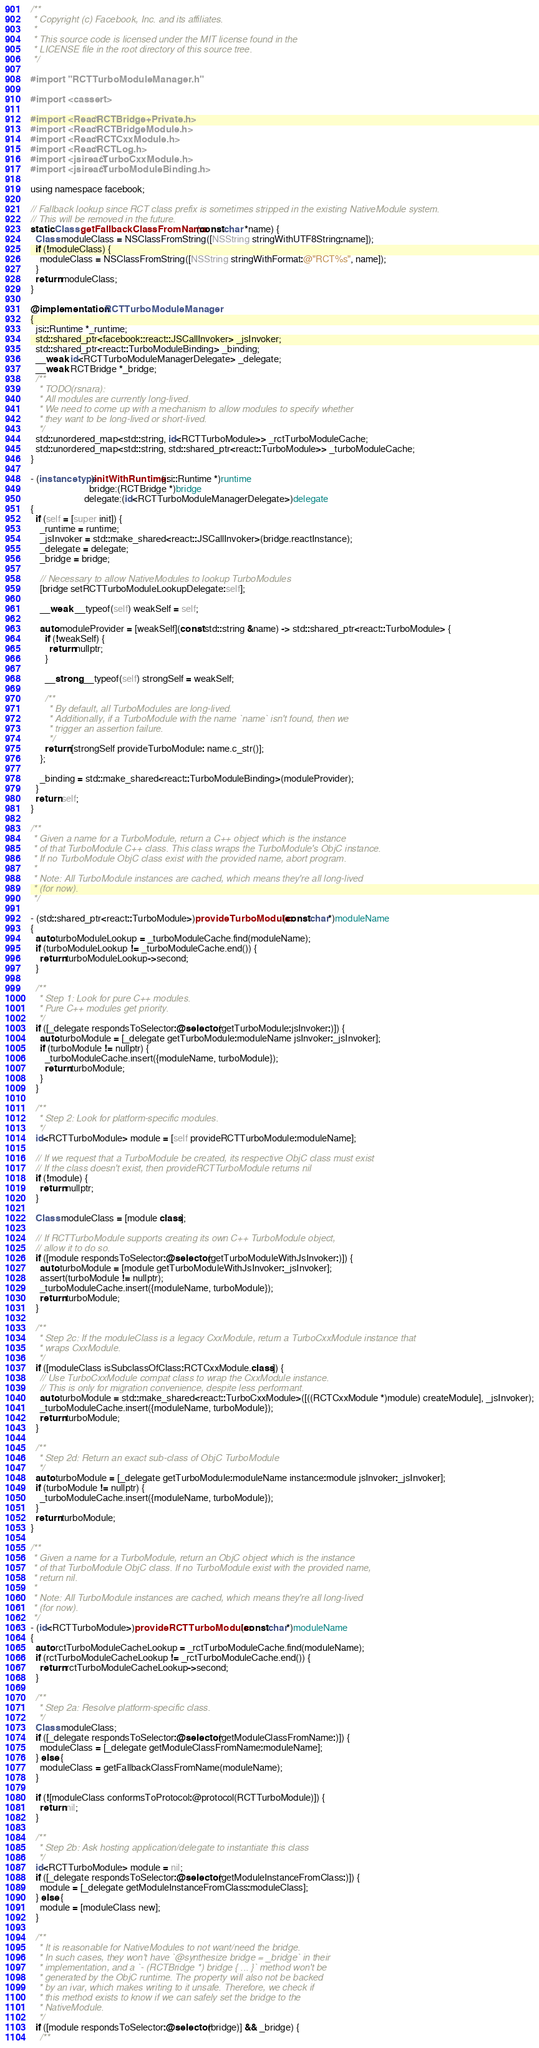<code> <loc_0><loc_0><loc_500><loc_500><_ObjectiveC_>/**
 * Copyright (c) Facebook, Inc. and its affiliates.
 *
 * This source code is licensed under the MIT license found in the
 * LICENSE file in the root directory of this source tree.
 */

#import "RCTTurboModuleManager.h"

#import <cassert>

#import <React/RCTBridge+Private.h>
#import <React/RCTBridgeModule.h>
#import <React/RCTCxxModule.h>
#import <React/RCTLog.h>
#import <jsireact/TurboCxxModule.h>
#import <jsireact/TurboModuleBinding.h>

using namespace facebook;

// Fallback lookup since RCT class prefix is sometimes stripped in the existing NativeModule system.
// This will be removed in the future.
static Class getFallbackClassFromName(const char *name) {
  Class moduleClass = NSClassFromString([NSString stringWithUTF8String:name]);
  if (!moduleClass) {
    moduleClass = NSClassFromString([NSString stringWithFormat:@"RCT%s", name]);
  }
  return moduleClass;
}

@implementation RCTTurboModuleManager
{
  jsi::Runtime *_runtime;
  std::shared_ptr<facebook::react::JSCallInvoker> _jsInvoker;
  std::shared_ptr<react::TurboModuleBinding> _binding;
  __weak id<RCTTurboModuleManagerDelegate> _delegate;
  __weak RCTBridge *_bridge;
  /**
   * TODO(rsnara):
   * All modules are currently long-lived.
   * We need to come up with a mechanism to allow modules to specify whether
   * they want to be long-lived or short-lived.
   */
  std::unordered_map<std::string, id<RCTTurboModule>> _rctTurboModuleCache;
  std::unordered_map<std::string, std::shared_ptr<react::TurboModule>> _turboModuleCache;
}

- (instancetype)initWithRuntime:(jsi::Runtime *)runtime
                         bridge:(RCTBridge *)bridge
                       delegate:(id<RCTTurboModuleManagerDelegate>)delegate
{
  if (self = [super init]) {
    _runtime = runtime;
    _jsInvoker = std::make_shared<react::JSCallInvoker>(bridge.reactInstance);
    _delegate = delegate;
    _bridge = bridge;

    // Necessary to allow NativeModules to lookup TurboModules
    [bridge setRCTTurboModuleLookupDelegate:self];

    __weak __typeof(self) weakSelf = self;

    auto moduleProvider = [weakSelf](const std::string &name) -> std::shared_ptr<react::TurboModule> {
      if (!weakSelf) {
        return nullptr;
      }

      __strong __typeof(self) strongSelf = weakSelf;

      /**
       * By default, all TurboModules are long-lived.
       * Additionally, if a TurboModule with the name `name` isn't found, then we
       * trigger an assertion failure.
       */
      return [strongSelf provideTurboModule: name.c_str()];
    };

    _binding = std::make_shared<react::TurboModuleBinding>(moduleProvider);
  }
  return self;
}

/**
 * Given a name for a TurboModule, return a C++ object which is the instance
 * of that TurboModule C++ class. This class wraps the TurboModule's ObjC instance.
 * If no TurboModule ObjC class exist with the provided name, abort program.
 *
 * Note: All TurboModule instances are cached, which means they're all long-lived
 * (for now).
 */

- (std::shared_ptr<react::TurboModule>)provideTurboModule:(const char*)moduleName
{
  auto turboModuleLookup = _turboModuleCache.find(moduleName);
  if (turboModuleLookup != _turboModuleCache.end()) {
    return turboModuleLookup->second;
  }

  /**
   * Step 1: Look for pure C++ modules.
   * Pure C++ modules get priority.
   */
  if ([_delegate respondsToSelector:@selector(getTurboModule:jsInvoker:)]) {
    auto turboModule = [_delegate getTurboModule:moduleName jsInvoker:_jsInvoker];
    if (turboModule != nullptr) {
      _turboModuleCache.insert({moduleName, turboModule});
      return turboModule;
    }
  }

  /**
   * Step 2: Look for platform-specific modules.
   */
  id<RCTTurboModule> module = [self provideRCTTurboModule:moduleName];

  // If we request that a TurboModule be created, its respective ObjC class must exist
  // If the class doesn't exist, then provideRCTTurboModule returns nil
  if (!module) {
    return nullptr;
  }

  Class moduleClass = [module class];

  // If RCTTurboModule supports creating its own C++ TurboModule object,
  // allow it to do so.
  if ([module respondsToSelector:@selector(getTurboModuleWithJsInvoker:)]) {
    auto turboModule = [module getTurboModuleWithJsInvoker:_jsInvoker];
    assert(turboModule != nullptr);
    _turboModuleCache.insert({moduleName, turboModule});
    return turboModule;
  }

  /**
   * Step 2c: If the moduleClass is a legacy CxxModule, return a TurboCxxModule instance that
   * wraps CxxModule.
   */
  if ([moduleClass isSubclassOfClass:RCTCxxModule.class]) {
    // Use TurboCxxModule compat class to wrap the CxxModule instance.
    // This is only for migration convenience, despite less performant.
    auto turboModule = std::make_shared<react::TurboCxxModule>([((RCTCxxModule *)module) createModule], _jsInvoker);
    _turboModuleCache.insert({moduleName, turboModule});
    return turboModule;
  }

  /**
   * Step 2d: Return an exact sub-class of ObjC TurboModule
   */
  auto turboModule = [_delegate getTurboModule:moduleName instance:module jsInvoker:_jsInvoker];
  if (turboModule != nullptr) {
    _turboModuleCache.insert({moduleName, turboModule});
  }
  return turboModule;
}

/**
 * Given a name for a TurboModule, return an ObjC object which is the instance
 * of that TurboModule ObjC class. If no TurboModule exist with the provided name,
 * return nil.
 *
 * Note: All TurboModule instances are cached, which means they're all long-lived
 * (for now).
 */
- (id<RCTTurboModule>)provideRCTTurboModule:(const char*)moduleName
{
  auto rctTurboModuleCacheLookup = _rctTurboModuleCache.find(moduleName);
  if (rctTurboModuleCacheLookup != _rctTurboModuleCache.end()) {
    return rctTurboModuleCacheLookup->second;
  }

  /**
   * Step 2a: Resolve platform-specific class.
   */
  Class moduleClass;
  if ([_delegate respondsToSelector:@selector(getModuleClassFromName:)]) {
    moduleClass = [_delegate getModuleClassFromName:moduleName];
  } else {
    moduleClass = getFallbackClassFromName(moduleName);
  }

  if (![moduleClass conformsToProtocol:@protocol(RCTTurboModule)]) {
    return nil;
  }

  /**
   * Step 2b: Ask hosting application/delegate to instantiate this class
   */
  id<RCTTurboModule> module = nil;
  if ([_delegate respondsToSelector:@selector(getModuleInstanceFromClass:)]) {
    module = [_delegate getModuleInstanceFromClass:moduleClass];
  } else {
    module = [moduleClass new];
  }

  /**
   * It is reasonable for NativeModules to not want/need the bridge.
   * In such cases, they won't have `@synthesize bridge = _bridge` in their
   * implementation, and a `- (RCTBridge *) bridge { ... }` method won't be
   * generated by the ObjC runtime. The property will also not be backed
   * by an ivar, which makes writing to it unsafe. Therefore, we check if
   * this method exists to know if we can safely set the bridge to the
   * NativeModule.
   */
  if ([module respondsToSelector:@selector(bridge)] && _bridge) {
    /**</code> 